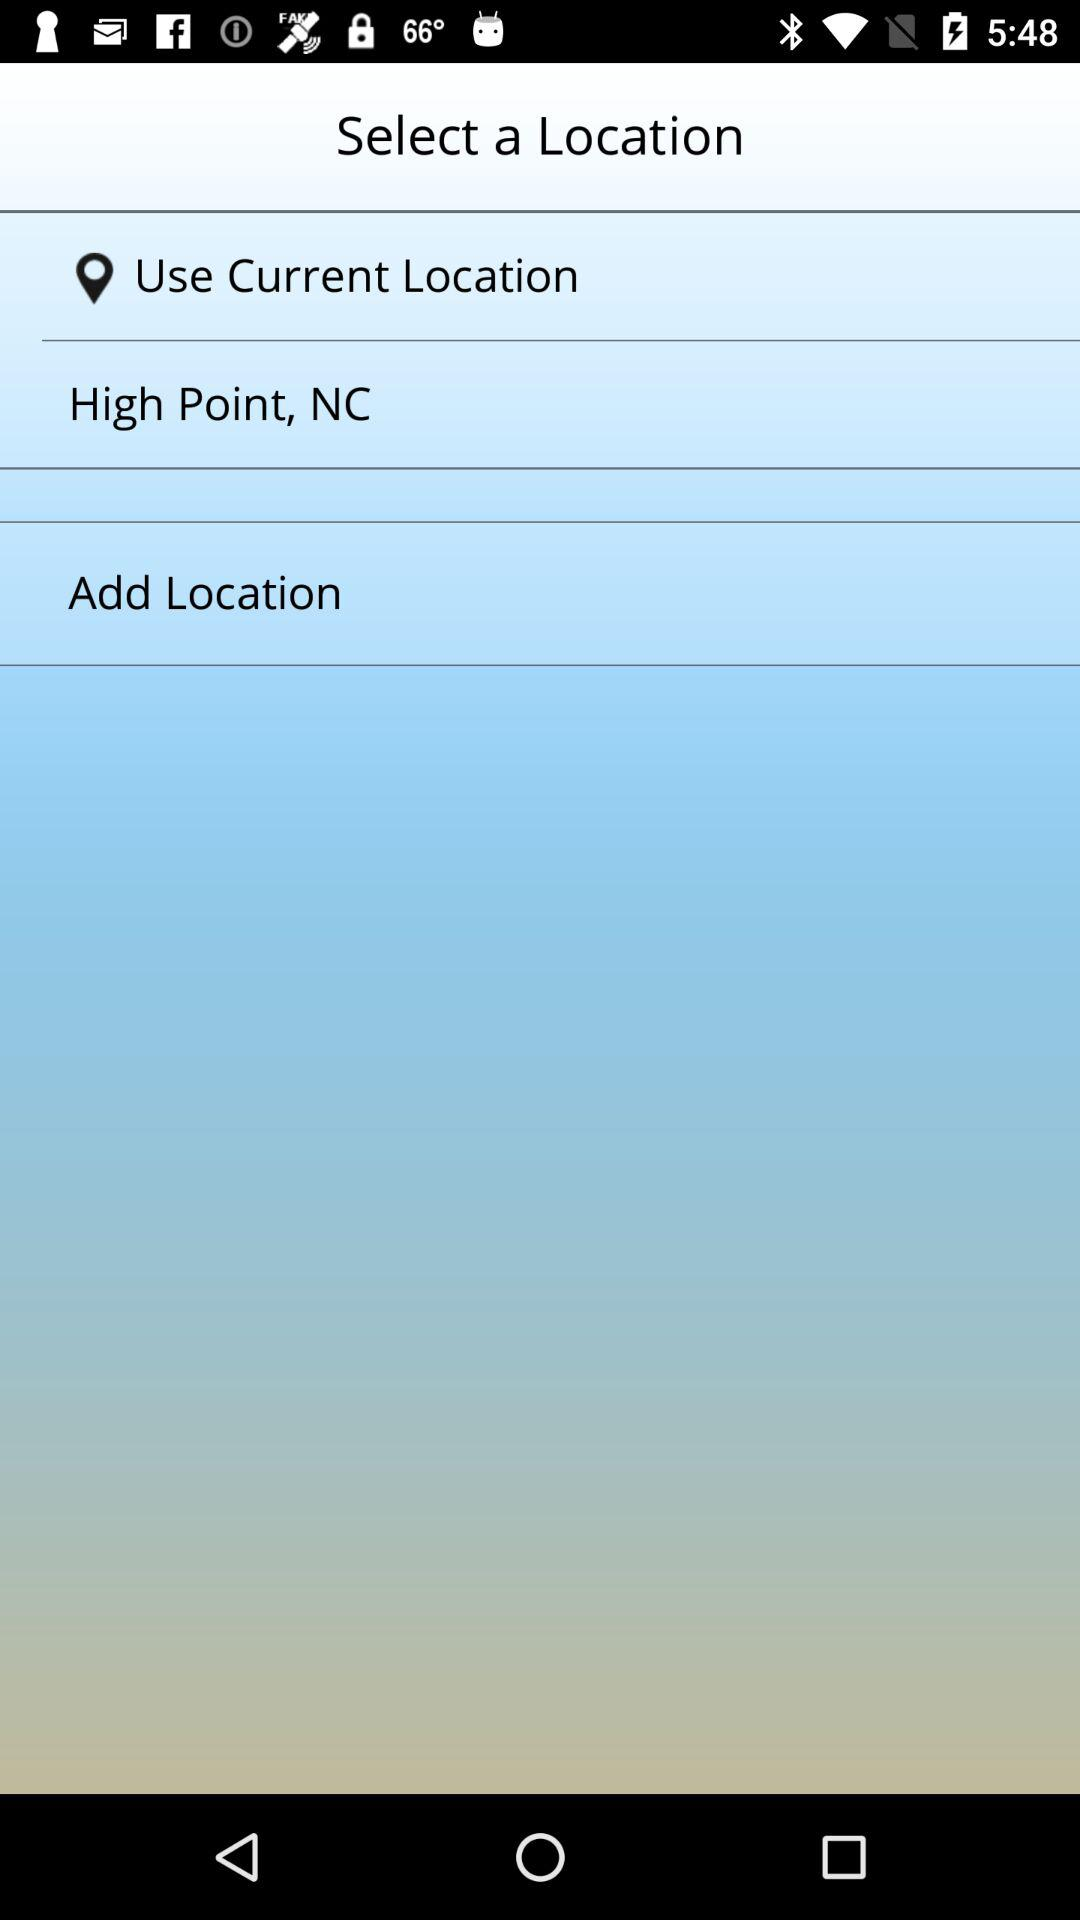What is the given location? The given location is High Point, NC. 